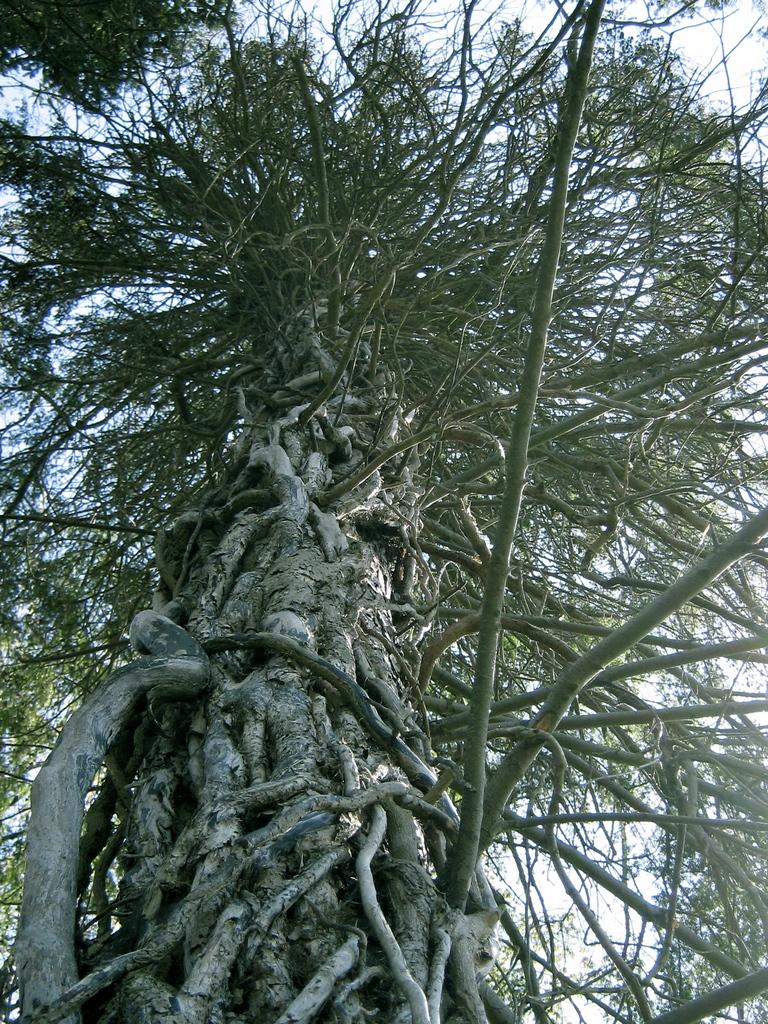What is the main subject in the center of the image? There is an object in the center of the image that appears to be a tree. What else can be seen in the image besides the tree? There are other objects visible in the image. What can be seen in the background of the image? The sky is visible in the background of the image. Where was the image taken? The image was taken outside. What time is displayed on the watch in the image? There is no watch present in the image. How does the angle of the tree affect the image? The angle of the tree does not affect the image, as the image is a still photograph and not a video or animation. 